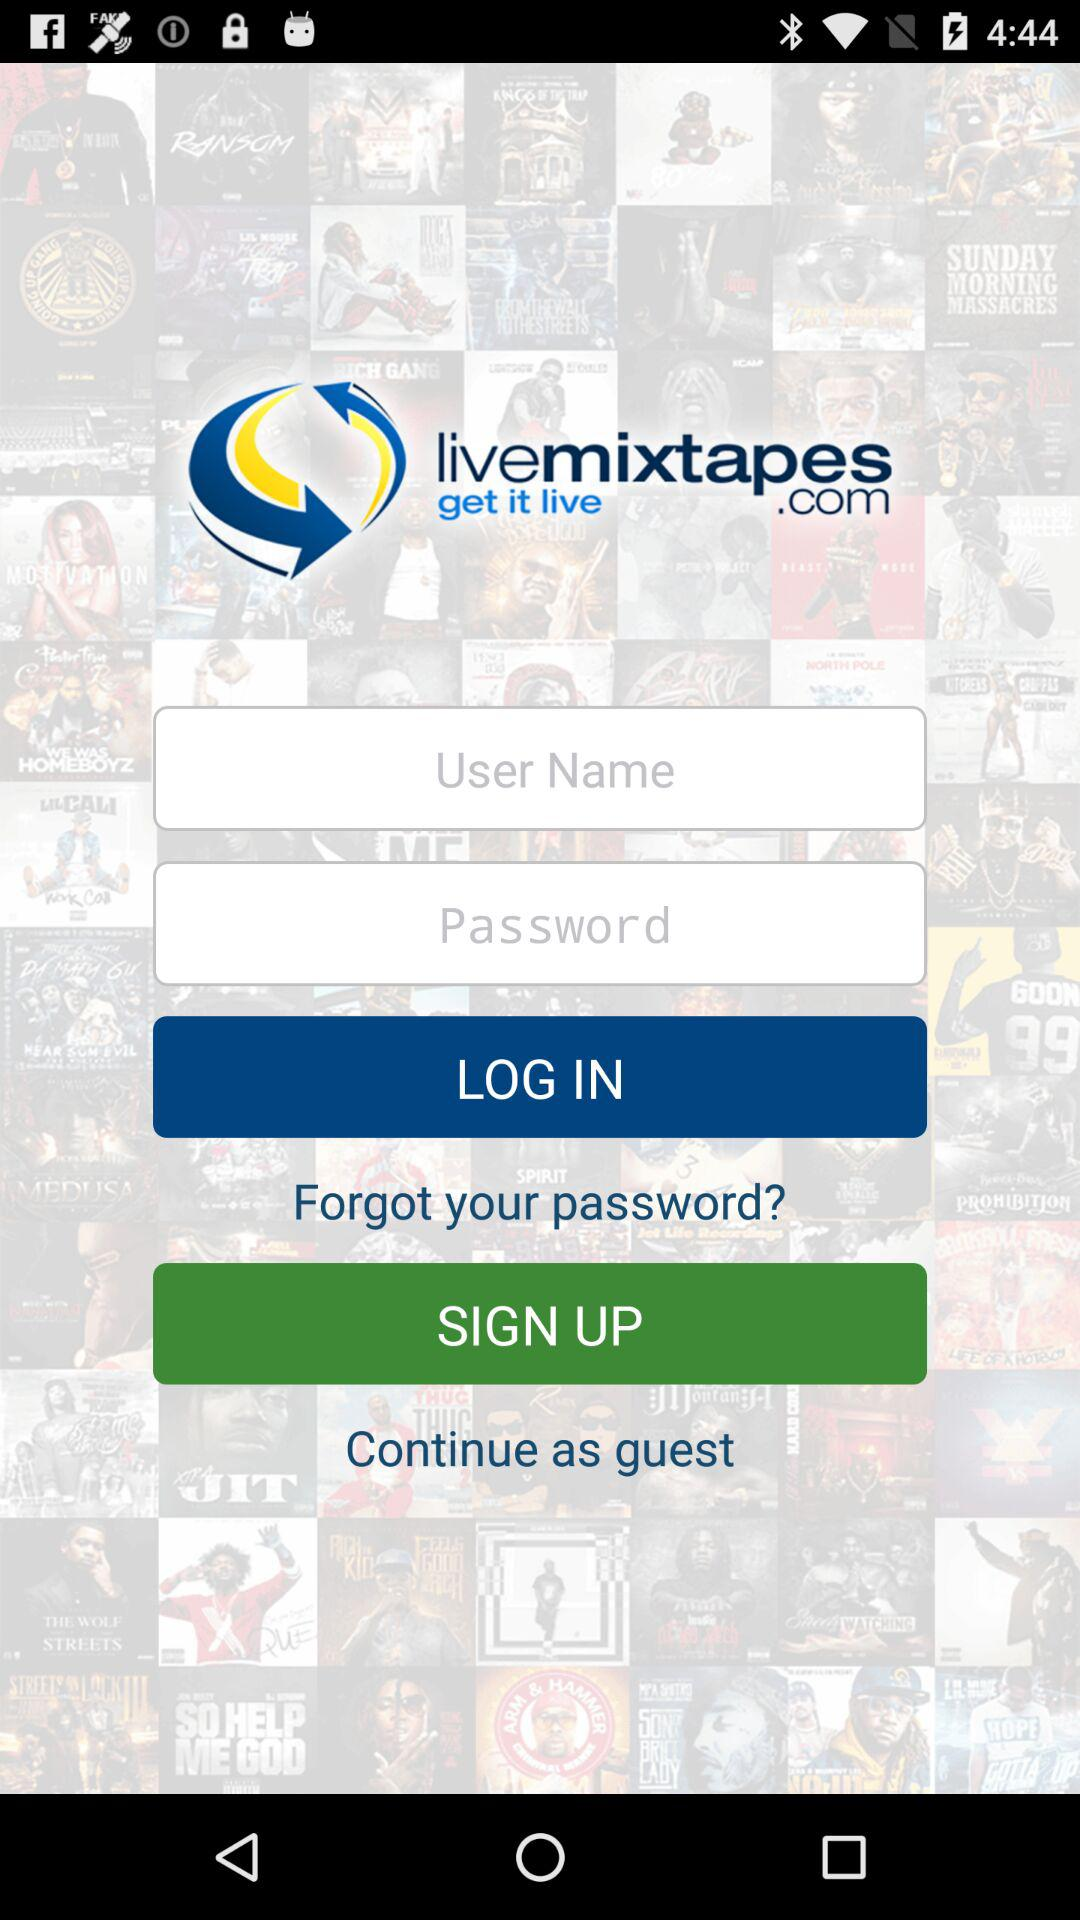What are the requirements to get a log in? To get a log in, a username and password are required. 